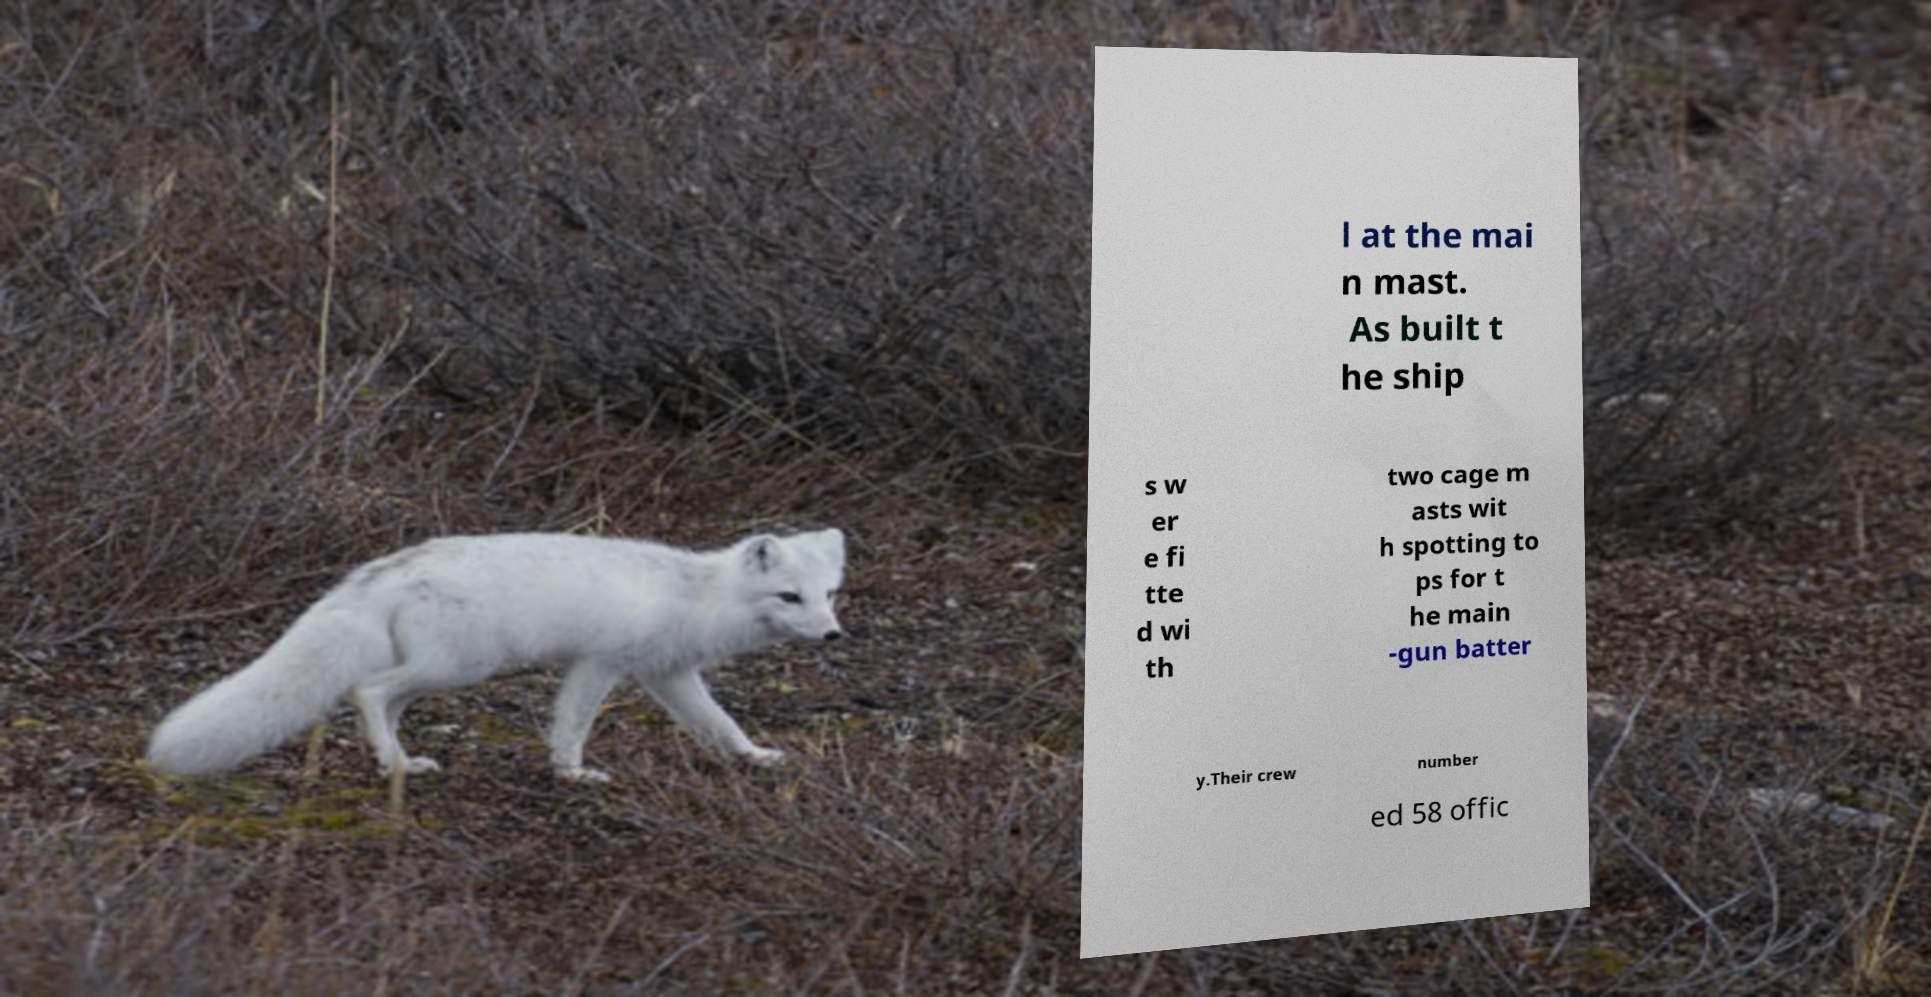I need the written content from this picture converted into text. Can you do that? l at the mai n mast. As built t he ship s w er e fi tte d wi th two cage m asts wit h spotting to ps for t he main -gun batter y.Their crew number ed 58 offic 